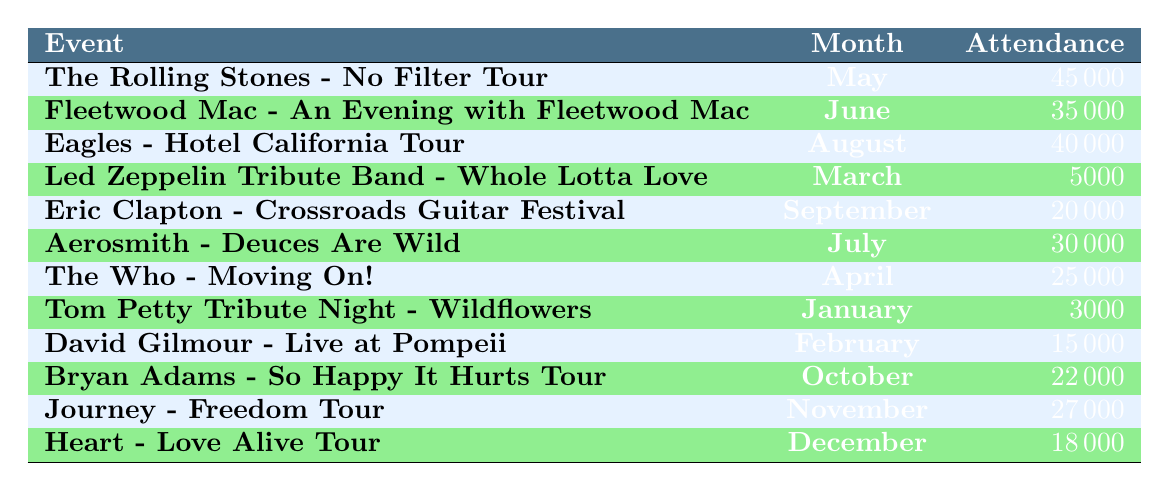What was the event with the highest attendance? The highest attendance value listed in the table is 45000, which corresponds to "The Rolling Stones - No Filter Tour" in May.
Answer: The Rolling Stones - No Filter Tour How many events had an attendance of over 30000? Reviewing the table, the events with over 30000 attendance are: "The Rolling Stones - No Filter Tour" (45000), "Eagles - Hotel California Tour" (40000), "Fleetwood Mac - An Evening with Fleetwood Mac" (35000), and "Aerosmith - Deuces Are Wild" (30000). That adds up to 4 events.
Answer: 4 What is the average attendance at the concerts? First, we sum the attendance values: 45000 + 35000 + 40000 + 5000 + 20000 + 30000 + 25000 + 3000 + 15000 + 22000 + 27000 + 18000 = 227000. There are 12 events, so the average is 227000 / 12 = 18916.67.
Answer: 18916.67 Was the event in April larger than the event in March? In the table, "The Who - Moving On!" in April has an attendance of 25000, and "Led Zeppelin Tribute Band - Whole Lotta Love" in March has an attendance of 5000. Since 25000 is greater than 5000, the event in April was indeed larger.
Answer: Yes What is the difference in attendance between the highest and lowest events? The highest attendance is 45000 (The Rolling Stones) and the lowest is 3000 (Tom Petty Tribute Night). The difference is 45000 - 3000 = 42000.
Answer: 42000 Which month had the event with the lowest attendance? The event with the lowest attendance was "Tom Petty Tribute Night - Wildflowers" in January, with an attendance of 3000. Since this is the minimum attendance noted, January is the month with the lowest attendance.
Answer: January What percentage of the total attendance does Fleetwood Mac's event represent? Fleetwood Mac's event had an attendance of 35000. The total attendance is 227000. The percentage is (35000 / 227000) * 100 = 15.43%.
Answer: 15.43% How many events had an attendance below 20000? The events below 20000 are: "Led Zeppelin Tribute Band - Whole Lotta Love" (5000), "Tom Petty Tribute Night - Wildflowers" (3000), and "David Gilmour - Live at Pompeii" (15000), totaling 3 events.
Answer: 3 